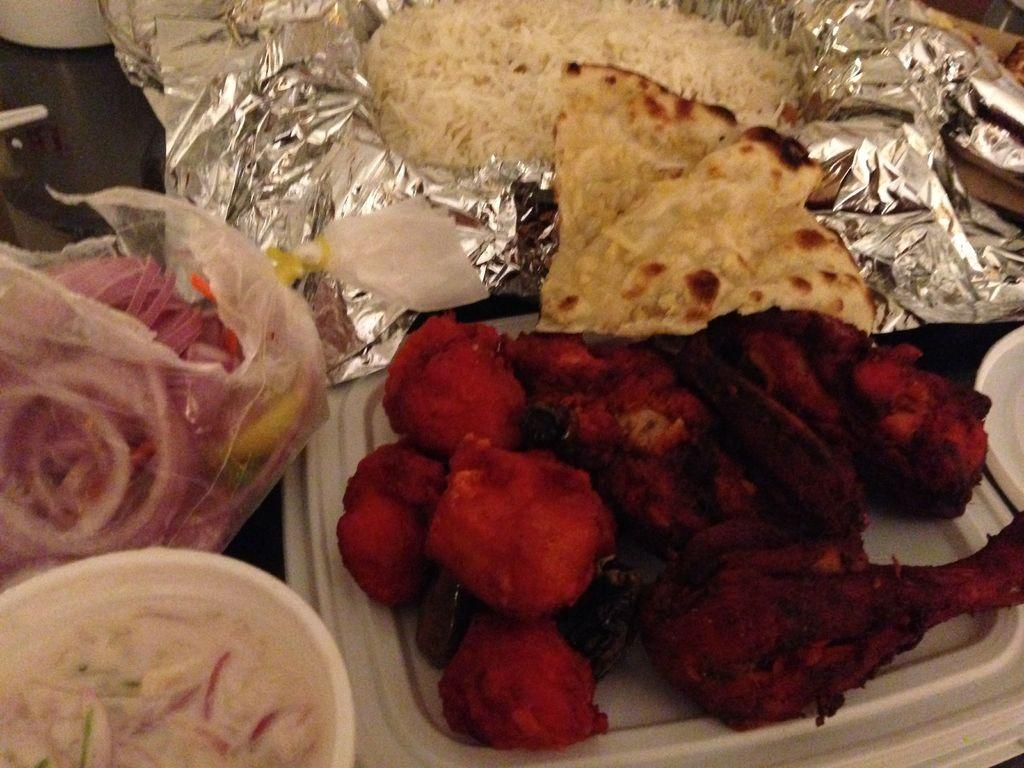What types of food can be seen in the image? There are different kinds of foods in the image. How are the foods stored or packaged in the image? The foods are placed in polythene containers and polythene covers. How many goldfish can be seen swimming in the polythene containers in the image? There are no goldfish present in the image; it only features different kinds of foods stored in polythene containers and covers. 